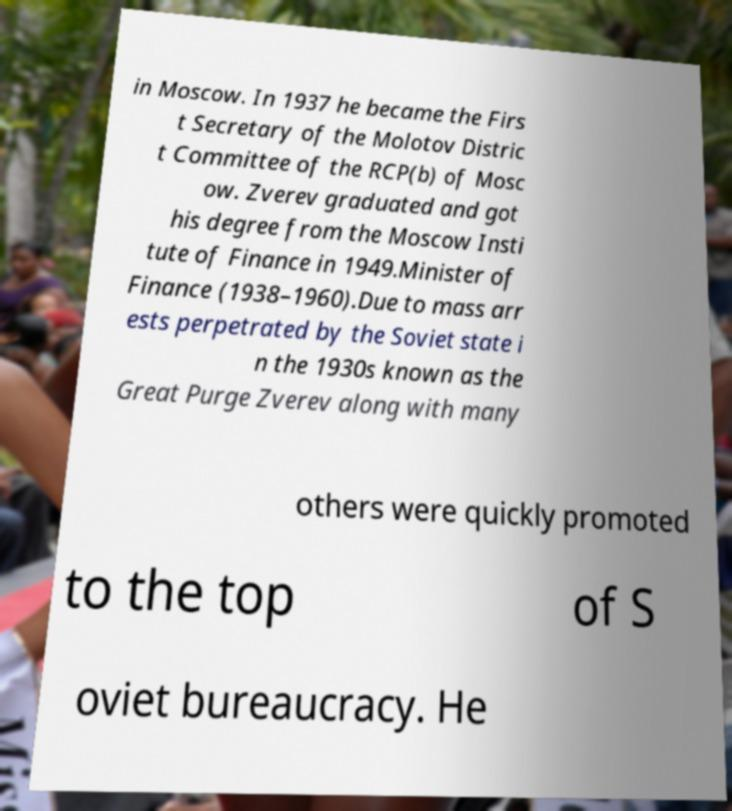Could you assist in decoding the text presented in this image and type it out clearly? in Moscow. In 1937 he became the Firs t Secretary of the Molotov Distric t Committee of the RCP(b) of Mosc ow. Zverev graduated and got his degree from the Moscow Insti tute of Finance in 1949.Minister of Finance (1938–1960).Due to mass arr ests perpetrated by the Soviet state i n the 1930s known as the Great Purge Zverev along with many others were quickly promoted to the top of S oviet bureaucracy. He 